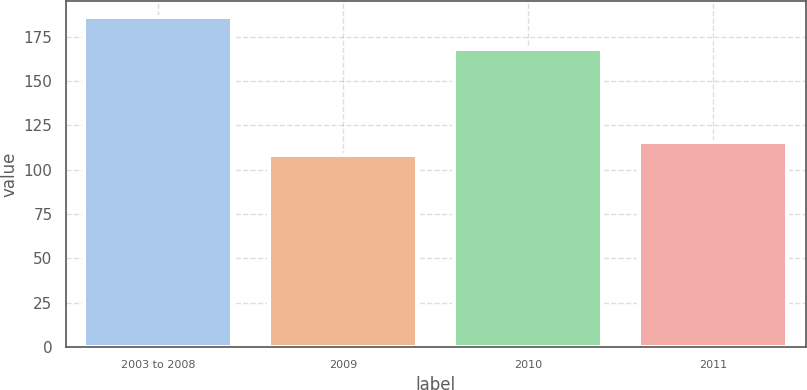Convert chart to OTSL. <chart><loc_0><loc_0><loc_500><loc_500><bar_chart><fcel>2003 to 2008<fcel>2009<fcel>2010<fcel>2011<nl><fcel>186<fcel>108<fcel>168<fcel>115.8<nl></chart> 